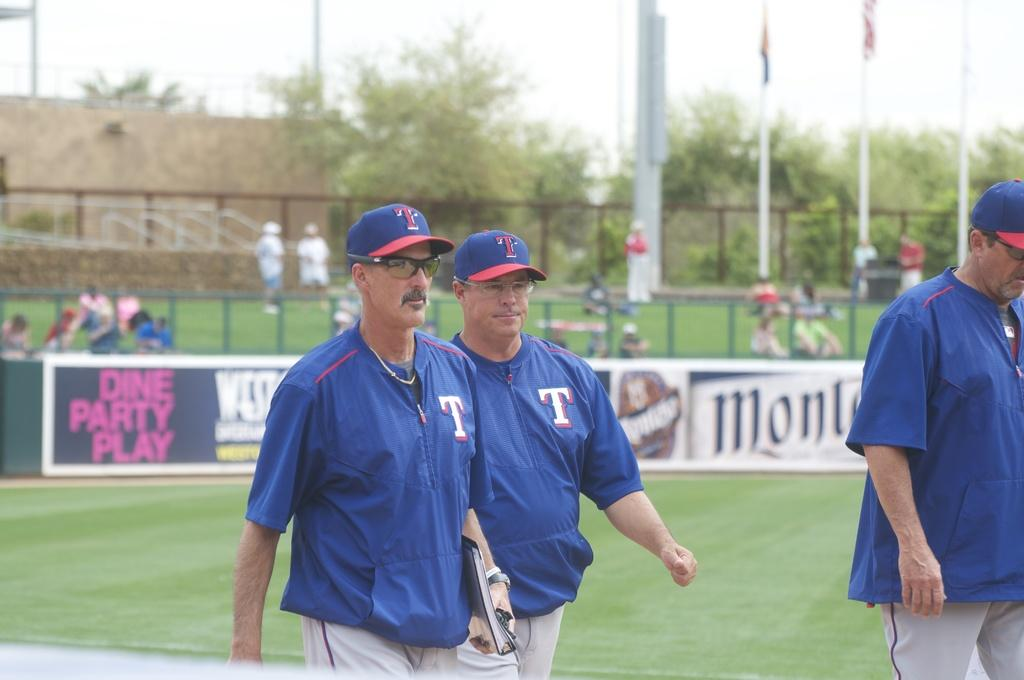<image>
Write a terse but informative summary of the picture. baseball coaches wearing clothes that have a 't' on them 